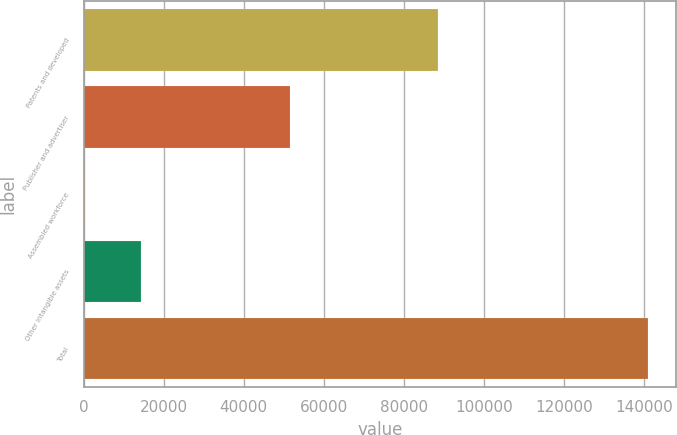Convert chart. <chart><loc_0><loc_0><loc_500><loc_500><bar_chart><fcel>Patents and developed<fcel>Publisher and advertiser<fcel>Assembled workforce<fcel>Other intangible assets<fcel>Total<nl><fcel>88453<fcel>51497<fcel>246<fcel>14322.9<fcel>141015<nl></chart> 